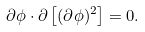<formula> <loc_0><loc_0><loc_500><loc_500>\partial \phi \cdot \partial \left [ ( \partial \phi ) ^ { 2 } \right ] = 0 .</formula> 